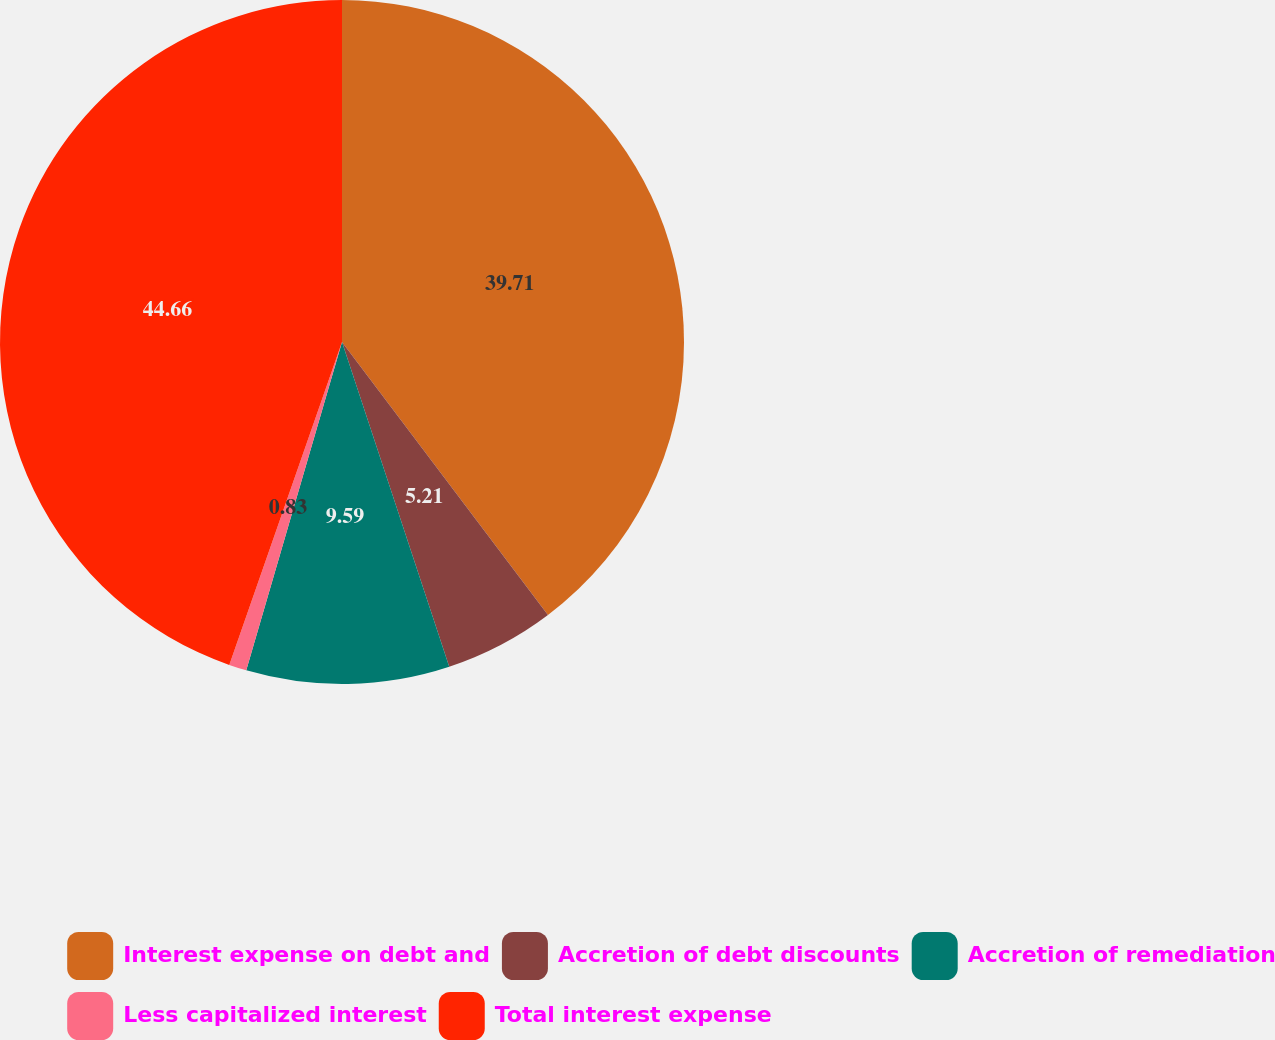<chart> <loc_0><loc_0><loc_500><loc_500><pie_chart><fcel>Interest expense on debt and<fcel>Accretion of debt discounts<fcel>Accretion of remediation<fcel>Less capitalized interest<fcel>Total interest expense<nl><fcel>39.71%<fcel>5.21%<fcel>9.59%<fcel>0.83%<fcel>44.65%<nl></chart> 